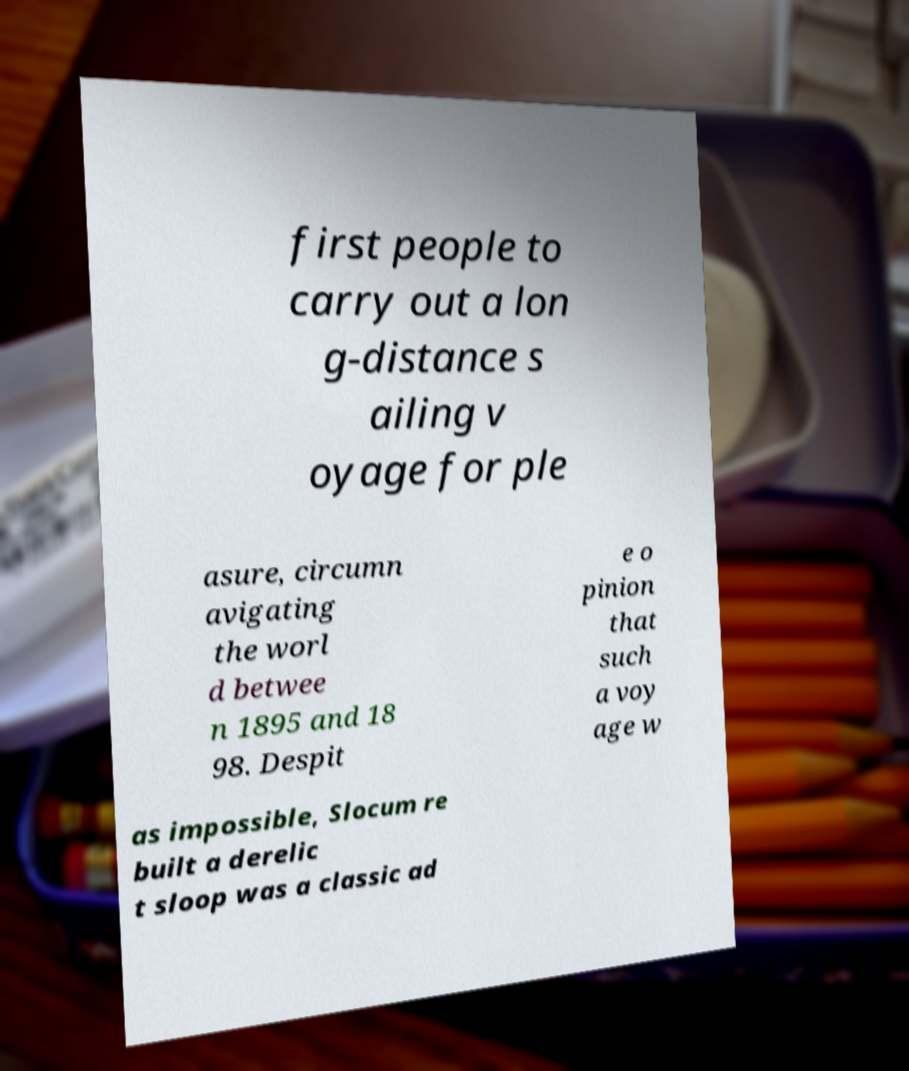For documentation purposes, I need the text within this image transcribed. Could you provide that? first people to carry out a lon g-distance s ailing v oyage for ple asure, circumn avigating the worl d betwee n 1895 and 18 98. Despit e o pinion that such a voy age w as impossible, Slocum re built a derelic t sloop was a classic ad 